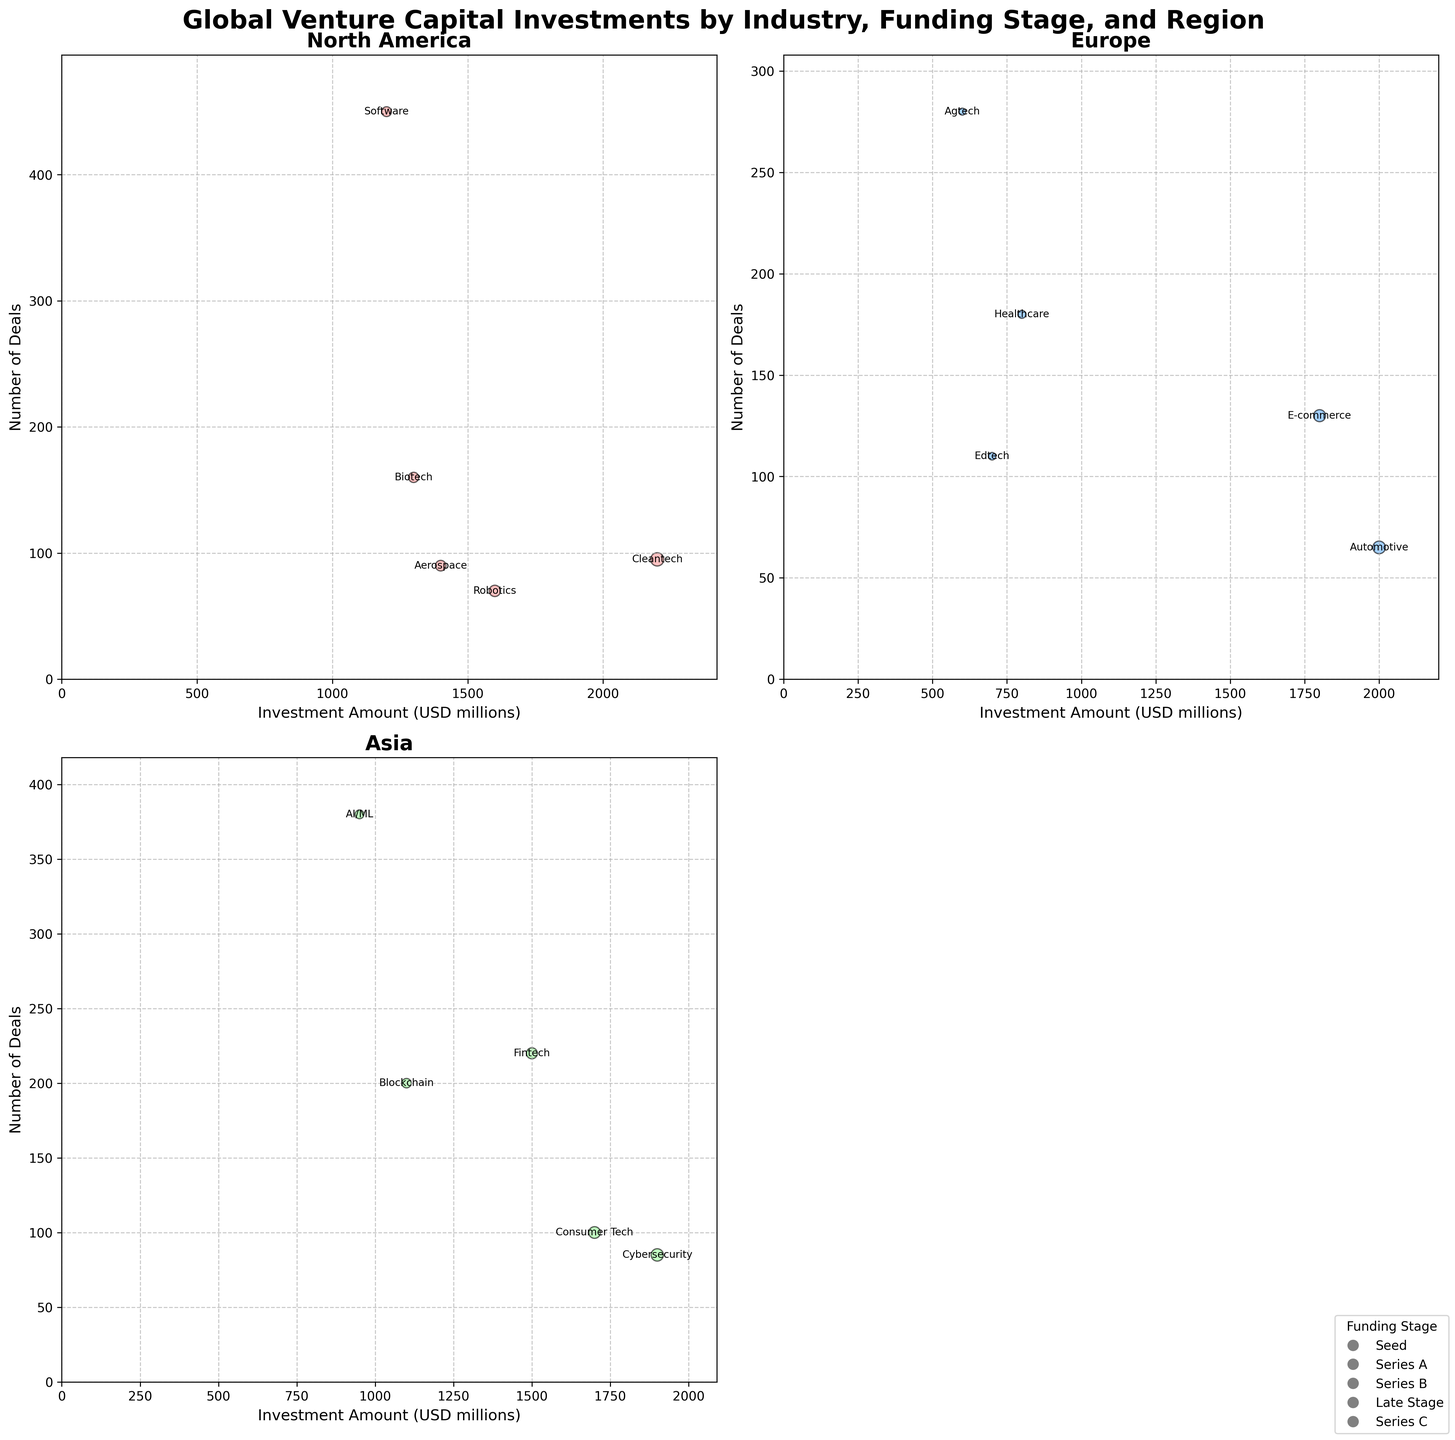How many industries are represented in the North America subplot? In the North America subplot, each bubble represents one industry. By counting the number of annotated bubbles, you can determine the number of industries.
Answer: 6 Which region has the largest investment amount for a single industry, and what is the industry? By inspecting the size of the bubbles (larger size means larger investment) and checking the values, the largest bubble represents Cleantech in North America with an investment of 2200 USD millions.
Answer: North America, Cleantech What is the average number of deals for Seed stage investments across all regions? First, identify the Seed stage investments: Software (450), AI/ML (380), Agtech (280). Next, calculate the sum of these deals: 450 + 380 + 280 = 1110. Finally, divide by the number of Seed stage instances: 1110 / 3 = 370.
Answer: 370 Which industry in Asia has the highest number of deals? By checking the y-axis values and the annotations in the Asia subplot, AI/ML has the highest number of deals with 380.
Answer: AI/ML Are there more Seed stage investments in Europe or Asia? Identify the Seed stage investments in each region and count the bubbles. Europe has Agtech (1), Asia has AI/ML (1). Both regions have 1 Seed stage investment.
Answer: Equal What is the total investment amount in Europe for Series A and Series C combined? Find the Series A and Series C investments in Europe: Healthcare (800), E-commerce (1800). Sum these amounts: 800 + 1800 = 2600 USD millions.
Answer: 2600 Which industry in North America has the smallest number of deals, and what is that number? By looking at the y-axis values and the annotations in the North America subplot, Robotics has the smallest number of deals with 70.
Answer: Robotics, 70 Compare the average investment amount in Late Stage for North America and Asia. Which is higher? First, find the investment amounts: North America (2200 for Cleantech), Asia (1900 for Cybersecurity). Average for North America is 2200, and for Asia is 1900. Therefore, North America has a higher average investment in Late Stage.
Answer: North America What is the difference in the number of deals between the fintech industry in Asia and the biotech industry in North America? Fintech in Asia has 220 deals, Biotech in North America has 160 deals. The difference is calculated as: 220 - 160 = 60.
Answer: 60 How many funding stages are represented in the plot? Each unique type of legend marker represents a funding stage. By counting the distinct legend markers, we see Seed, Series A, Series B, Series C, and Late Stage, making a total of 5 stages.
Answer: 5 